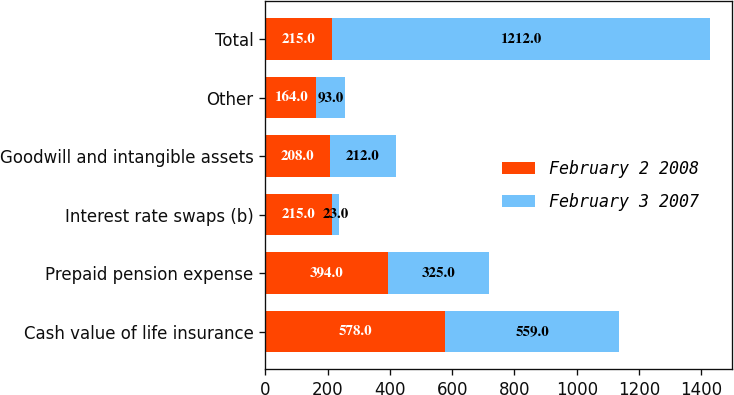<chart> <loc_0><loc_0><loc_500><loc_500><stacked_bar_chart><ecel><fcel>Cash value of life insurance<fcel>Prepaid pension expense<fcel>Interest rate swaps (b)<fcel>Goodwill and intangible assets<fcel>Other<fcel>Total<nl><fcel>February 2 2008<fcel>578<fcel>394<fcel>215<fcel>208<fcel>164<fcel>215<nl><fcel>February 3 2007<fcel>559<fcel>325<fcel>23<fcel>212<fcel>93<fcel>1212<nl></chart> 